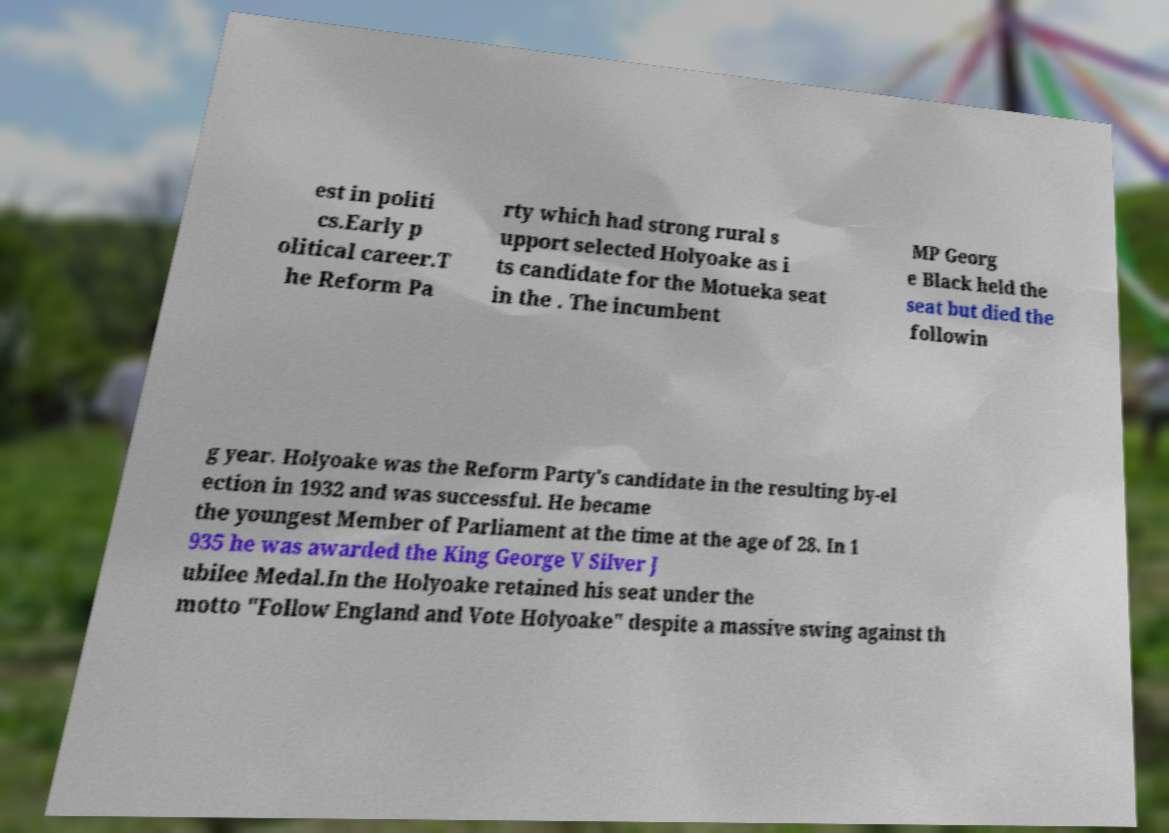Can you read and provide the text displayed in the image?This photo seems to have some interesting text. Can you extract and type it out for me? est in politi cs.Early p olitical career.T he Reform Pa rty which had strong rural s upport selected Holyoake as i ts candidate for the Motueka seat in the . The incumbent MP Georg e Black held the seat but died the followin g year. Holyoake was the Reform Party's candidate in the resulting by-el ection in 1932 and was successful. He became the youngest Member of Parliament at the time at the age of 28. In 1 935 he was awarded the King George V Silver J ubilee Medal.In the Holyoake retained his seat under the motto "Follow England and Vote Holyoake" despite a massive swing against th 